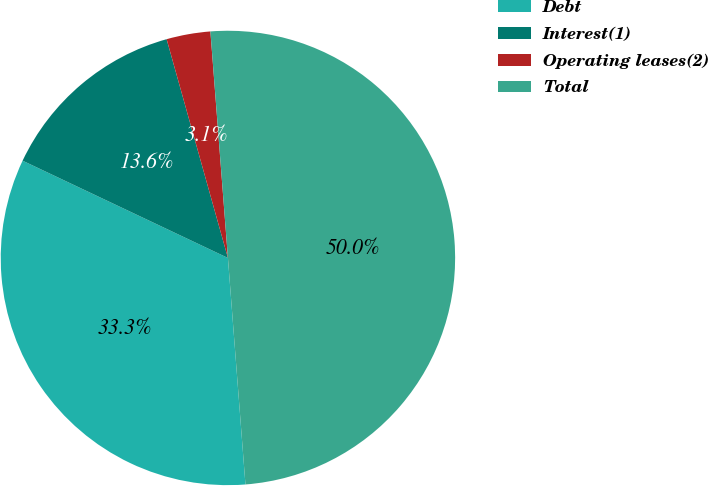Convert chart to OTSL. <chart><loc_0><loc_0><loc_500><loc_500><pie_chart><fcel>Debt<fcel>Interest(1)<fcel>Operating leases(2)<fcel>Total<nl><fcel>33.27%<fcel>13.61%<fcel>3.12%<fcel>50.0%<nl></chart> 